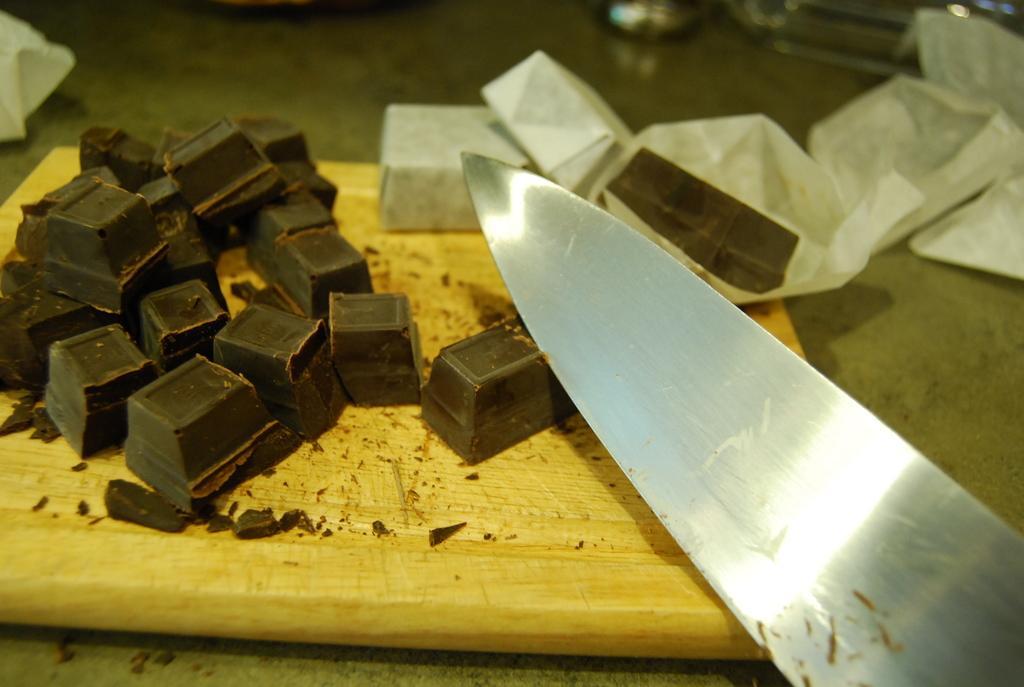Please provide a concise description of this image. In this picture we can see there is a knife, a wrapper and chocolates on an object and behind the object there are some items. 